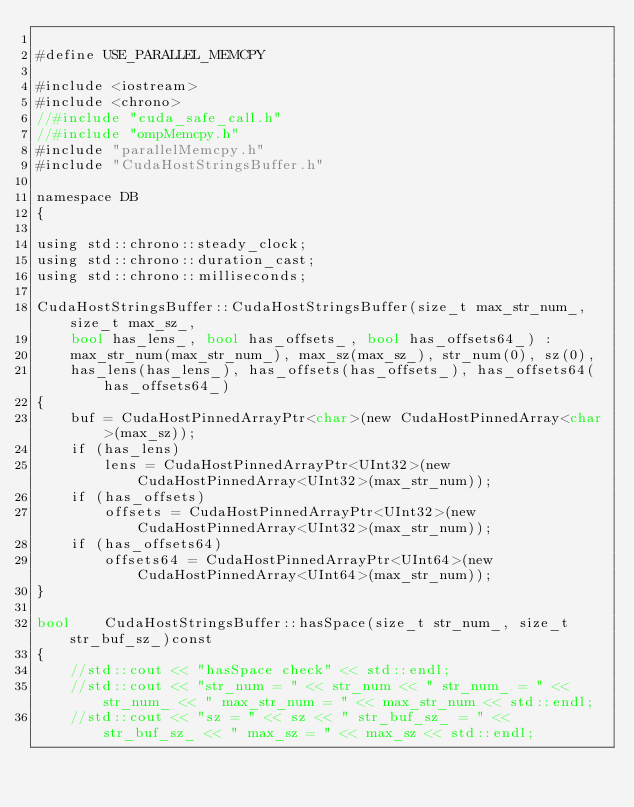<code> <loc_0><loc_0><loc_500><loc_500><_Cuda_>
#define USE_PARALLEL_MEMCPY

#include <iostream>
#include <chrono>
//#include "cuda_safe_call.h"
//#include "ompMemcpy.h"
#include "parallelMemcpy.h"
#include "CudaHostStringsBuffer.h"

namespace DB
{

using std::chrono::steady_clock;
using std::chrono::duration_cast;
using std::chrono::milliseconds;

CudaHostStringsBuffer::CudaHostStringsBuffer(size_t max_str_num_, size_t max_sz_,
    bool has_lens_, bool has_offsets_, bool has_offsets64_) : 
    max_str_num(max_str_num_), max_sz(max_sz_), str_num(0), sz(0),
    has_lens(has_lens_), has_offsets(has_offsets_), has_offsets64(has_offsets64_)
{
    buf = CudaHostPinnedArrayPtr<char>(new CudaHostPinnedArray<char>(max_sz));
    if (has_lens)
        lens = CudaHostPinnedArrayPtr<UInt32>(new CudaHostPinnedArray<UInt32>(max_str_num));
    if (has_offsets)
        offsets = CudaHostPinnedArrayPtr<UInt32>(new CudaHostPinnedArray<UInt32>(max_str_num));
    if (has_offsets64)
        offsets64 = CudaHostPinnedArrayPtr<UInt64>(new CudaHostPinnedArray<UInt64>(max_str_num));
}

bool    CudaHostStringsBuffer::hasSpace(size_t str_num_, size_t str_buf_sz_)const
{
    //std::cout << "hasSpace check" << std::endl;
    //std::cout << "str_num = " << str_num << " str_num_ = " << str_num_ << " max_str_num = " << max_str_num << std::endl;
    //std::cout << "sz = " << sz << " str_buf_sz_ = " << str_buf_sz_ << " max_sz = " << max_sz << std::endl;</code> 